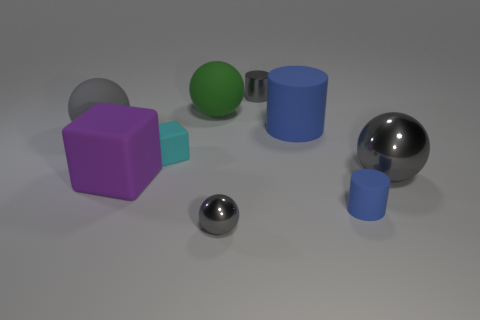Subtract all blue cubes. How many gray balls are left? 3 Subtract 2 balls. How many balls are left? 2 Add 1 large purple cubes. How many objects exist? 10 Subtract all balls. How many objects are left? 5 Add 2 large rubber spheres. How many large rubber spheres exist? 4 Subtract 0 gray blocks. How many objects are left? 9 Subtract all tiny yellow metal cylinders. Subtract all big spheres. How many objects are left? 6 Add 6 small objects. How many small objects are left? 10 